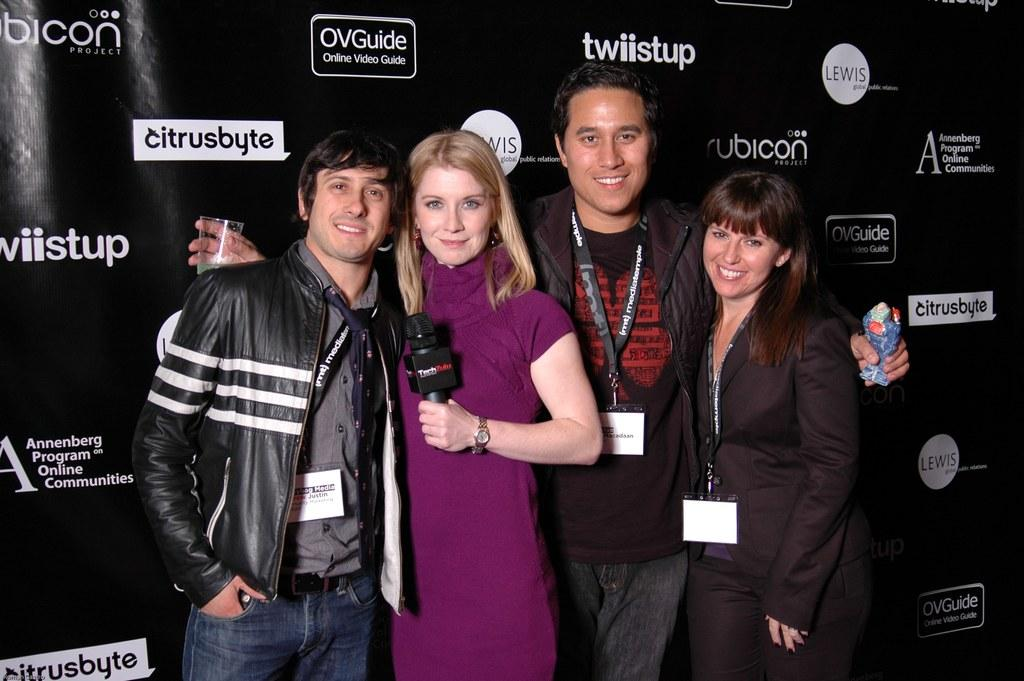Provide a one-sentence caption for the provided image. Two women and two men stand for a photo in front of a black backdrop that says "twiistup" and "citrusbyte.". 